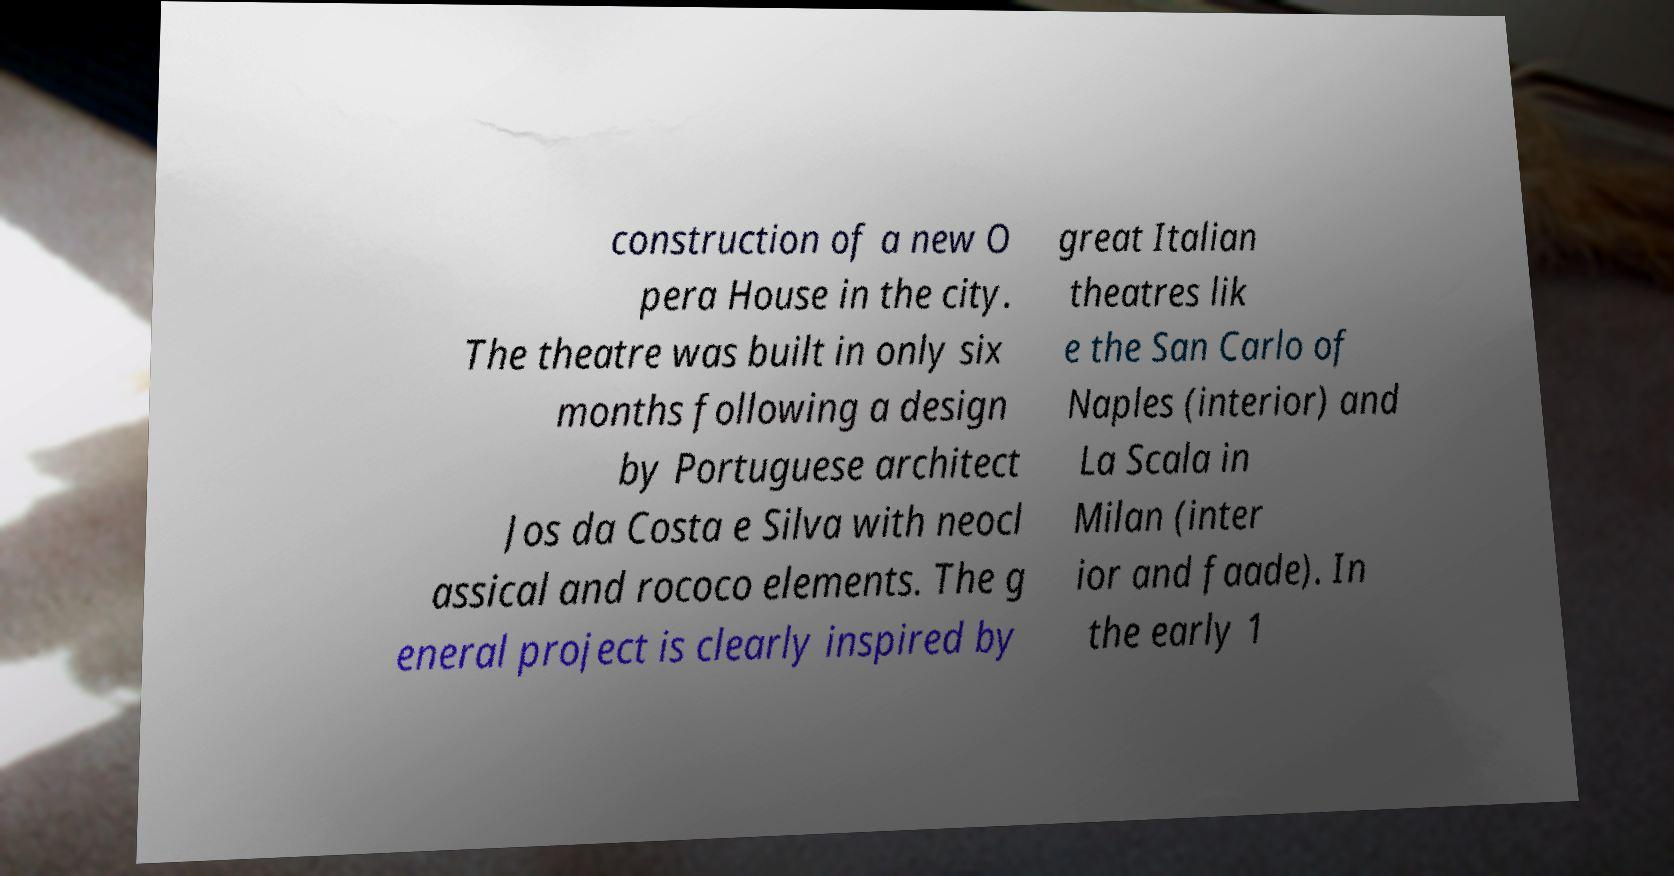Can you accurately transcribe the text from the provided image for me? construction of a new O pera House in the city. The theatre was built in only six months following a design by Portuguese architect Jos da Costa e Silva with neocl assical and rococo elements. The g eneral project is clearly inspired by great Italian theatres lik e the San Carlo of Naples (interior) and La Scala in Milan (inter ior and faade). In the early 1 